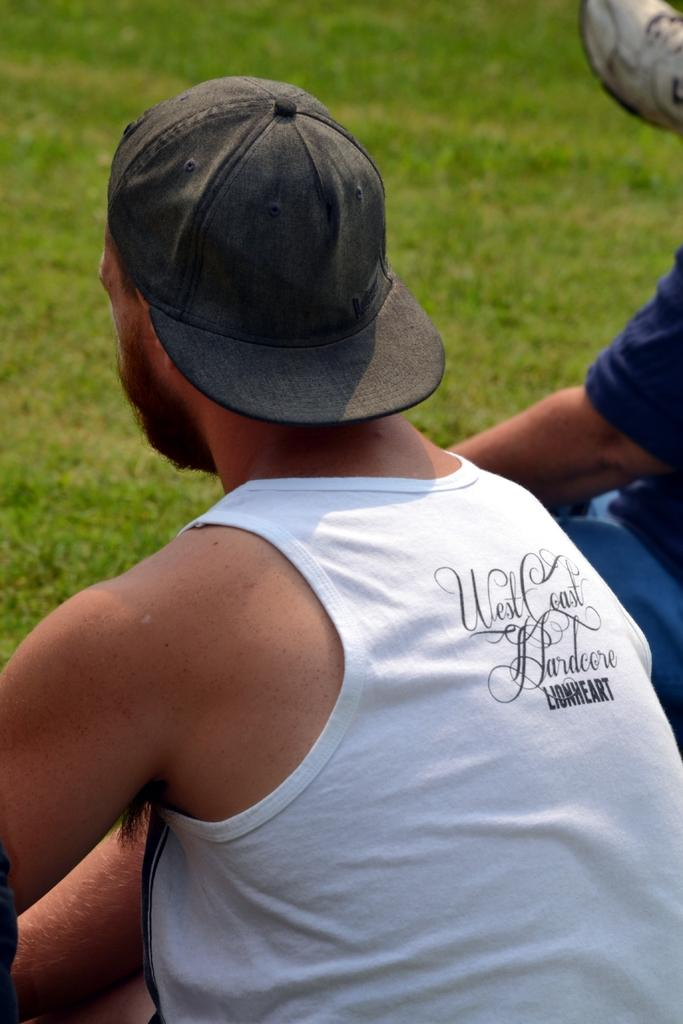Who or what is present in the image? There is a person in the image. What is the person wearing on their head? The person is wearing a cap. What type of clothing is the person wearing on their upper body? The person is wearing a white vest. Where is the person sitting in the image? The person is sitting on green grass. What type of twig is the person holding in the image? There is no twig present in the image. 